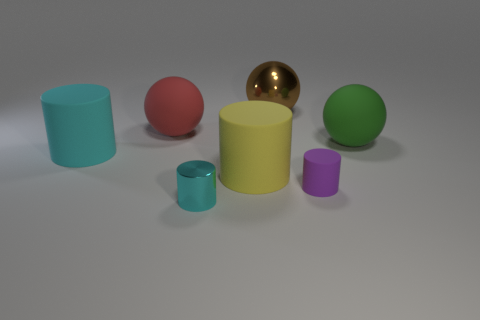Subtract all blue cylinders. Subtract all gray spheres. How many cylinders are left? 4 Add 1 large green cylinders. How many objects exist? 8 Subtract all cylinders. How many objects are left? 3 Subtract 0 blue cylinders. How many objects are left? 7 Subtract all gray matte cylinders. Subtract all shiny cylinders. How many objects are left? 6 Add 7 tiny purple cylinders. How many tiny purple cylinders are left? 8 Add 7 big gray rubber spheres. How many big gray rubber spheres exist? 7 